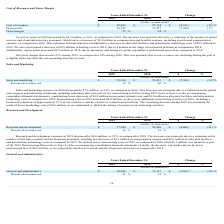According to Marin Software's financial document, What is the decrease in research and development expenses in 2019? According to the financial document, $4.6 million. The relevant text states: "arch and development expenses in 2019 decreased by $4.6 million, or 21%, as compared to 2018. The decrease was primarily due to a reduction in the..." Also, What led to the decrease in research and development expenses in 2019? reduction in the number of full-time research and development personnel. The document states: "ared to 2018. The decrease was primarily due to a reduction in the number of full-time research and development personnel, resulting in a decrease of ..." Also, What are the respective values of research and development expenses in 2018 and 2019? The document shows two values: $22,450 and $17,845 (in thousands). From the document: "Research and development $ 17,845 $ 22,450 $ (4,605) (21) % Research and development $ 17,845 $ 22,450 $ (4,605) (21) %..." Also, can you calculate: What is the total research and development expenses in 2018 and 2019? Based on the calculation: 22,450 + 17,845 , the result is 40295 (in thousands). This is based on the information: "Research and development $ 17,845 $ 22,450 $ (4,605) (21) % Research and development $ 17,845 $ 22,450 $ (4,605) (21) %..." The key data points involved are: 17,845, 22,450. Also, can you calculate: What is the average research and development expense in 2018 and 2019? To answer this question, I need to perform calculations using the financial data. The calculation is: (22,450 + 17,845)/2 , which equals 20147.5 (in thousands). This is based on the information: "Research and development $ 17,845 $ 22,450 $ (4,605) (21) % Research and development $ 17,845 $ 22,450 $ (4,605) (21) %..." The key data points involved are: 17,845, 22,450. Also, can you calculate: What is the value of the change in research and development expenses as a percentage of the company's 2018 expenses? Based on the calculation: 4,605/22,450 , the result is 20.51 (percentage). This is based on the information: "Research and development $ 17,845 $ 22,450 $ (4,605) (21) % Research and development $ 17,845 $ 22,450 $ (4,605) (21) %..." The key data points involved are: 22,450, 4,605. 